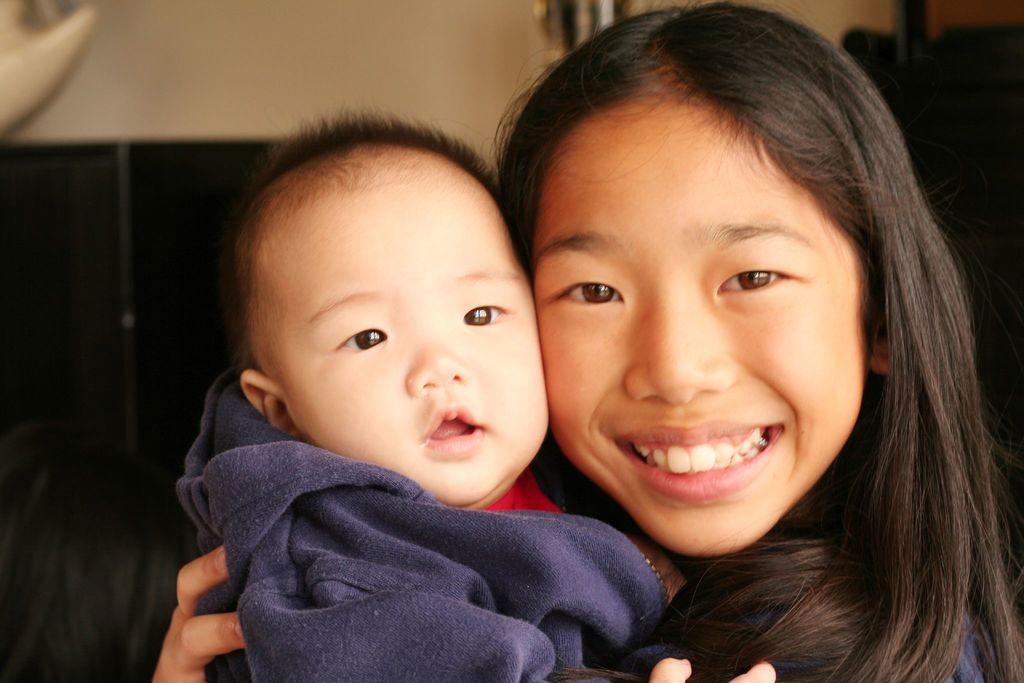In one or two sentences, can you explain what this image depicts? A girl is holding the baby in her hands and smiling. 